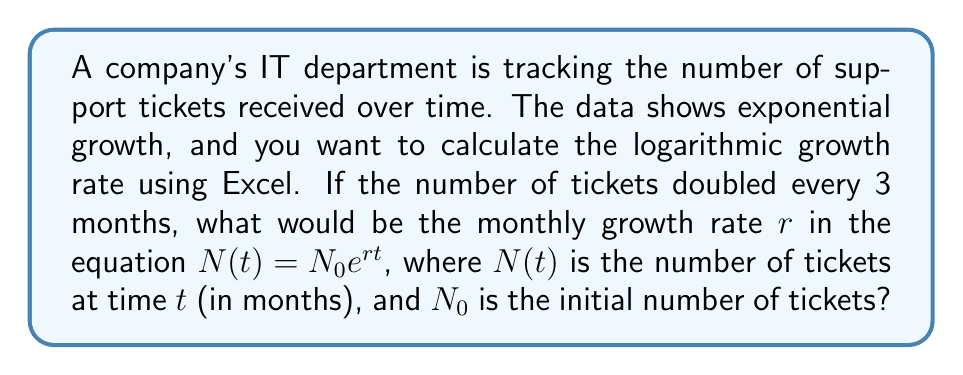Solve this math problem. To solve this problem, we'll follow these steps:

1. Identify the doubling time: 3 months

2. Use the doubling time formula:
   $N(t) = N_0 \cdot 2^{\frac{t}{3}}$

3. Convert this to the exponential form:
   $N(t) = N_0 \cdot e^{rt}$

4. Equate the exponents:
   $2^{\frac{t}{3}} = e^{rt}$

5. Take the natural logarithm of both sides:
   $\ln(2^{\frac{t}{3}}) = \ln(e^{rt})$

6. Simplify:
   $\frac{t}{3} \ln(2) = rt$

7. Solve for $r$:
   $r = \frac{\ln(2)}{3}$

8. Calculate the value:
   $r = \frac{0.693147...}{3} \approx 0.231049...$ per month

In Excel, you can calculate this using the formula:
=LN(2)/3

This gives the monthly growth rate $r$ in the exponential growth equation.
Answer: $r = \frac{\ln(2)}{3} \approx 0.231$ per month 